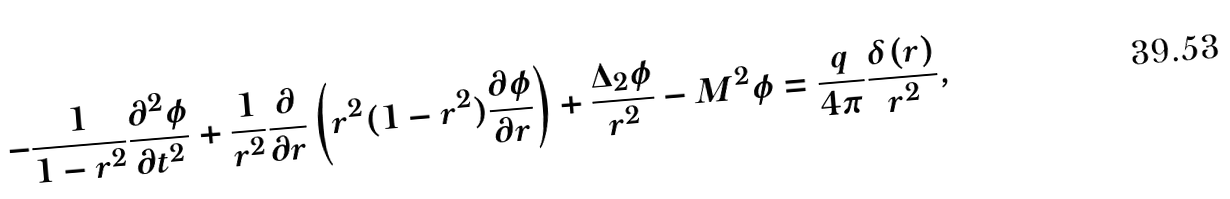Convert formula to latex. <formula><loc_0><loc_0><loc_500><loc_500>- \frac { 1 } { 1 - r ^ { 2 } } \frac { \partial ^ { 2 } \phi } { \partial t ^ { 2 } } + \frac { 1 } { r ^ { 2 } } \frac { \partial } { \partial r } \left ( r ^ { 2 } ( 1 - r ^ { 2 } ) \frac { \partial \phi } { \partial r } \right ) + \frac { \Delta _ { 2 } \phi } { r ^ { 2 } } - M ^ { 2 } \phi = \frac { q } { 4 \pi } \frac { \delta ( r ) } { r ^ { 2 } } ,</formula> 